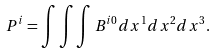<formula> <loc_0><loc_0><loc_500><loc_500>P ^ { i } = \int \int \int { B } ^ { i 0 } d x ^ { 1 } d x ^ { 2 } d x ^ { 3 } .</formula> 